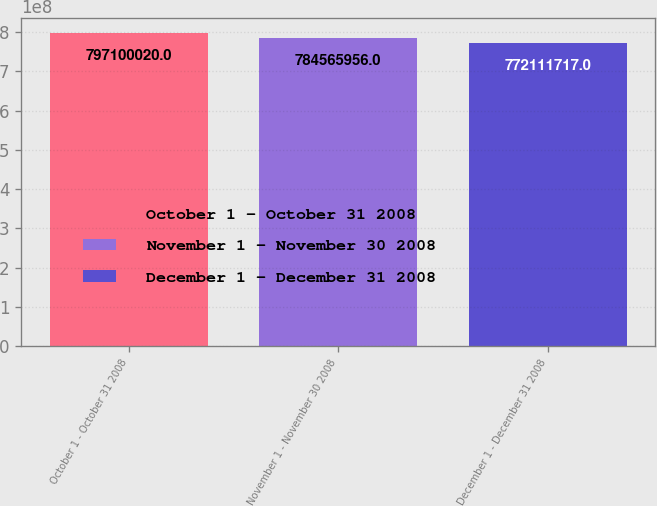Convert chart. <chart><loc_0><loc_0><loc_500><loc_500><bar_chart><fcel>October 1 - October 31 2008<fcel>November 1 - November 30 2008<fcel>December 1 - December 31 2008<nl><fcel>7.971e+08<fcel>7.84566e+08<fcel>7.72112e+08<nl></chart> 